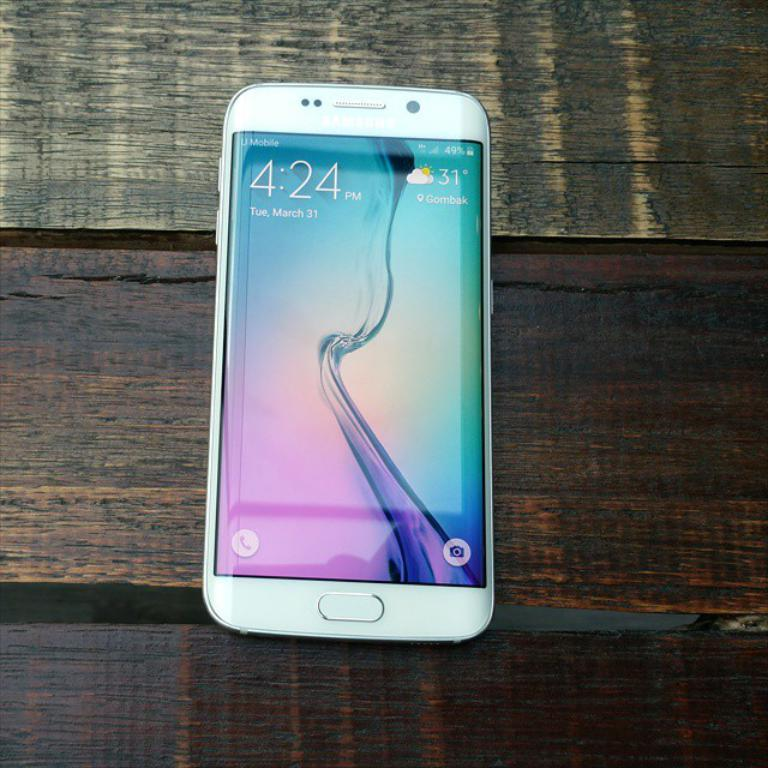Provide a one-sentence caption for the provided image. Samsung Phone with home screen open at the time 4:24 on March 31. 